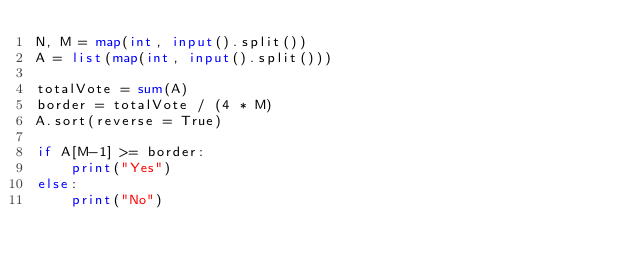<code> <loc_0><loc_0><loc_500><loc_500><_Python_>N, M = map(int, input().split())
A = list(map(int, input().split()))

totalVote = sum(A)
border = totalVote / (4 * M)
A.sort(reverse = True)

if A[M-1] >= border:
    print("Yes")
else:
    print("No")
</code> 